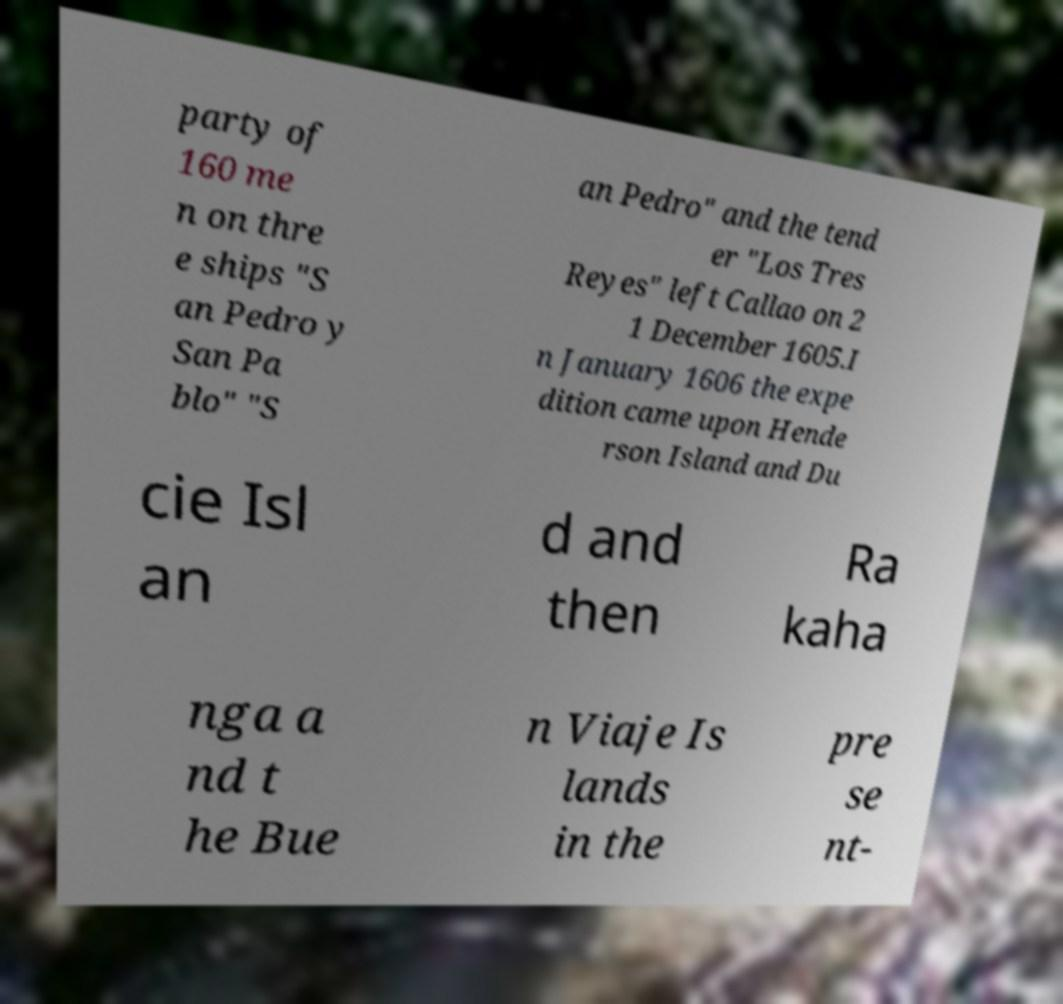There's text embedded in this image that I need extracted. Can you transcribe it verbatim? party of 160 me n on thre e ships "S an Pedro y San Pa blo" "S an Pedro" and the tend er "Los Tres Reyes" left Callao on 2 1 December 1605.I n January 1606 the expe dition came upon Hende rson Island and Du cie Isl an d and then Ra kaha nga a nd t he Bue n Viaje Is lands in the pre se nt- 